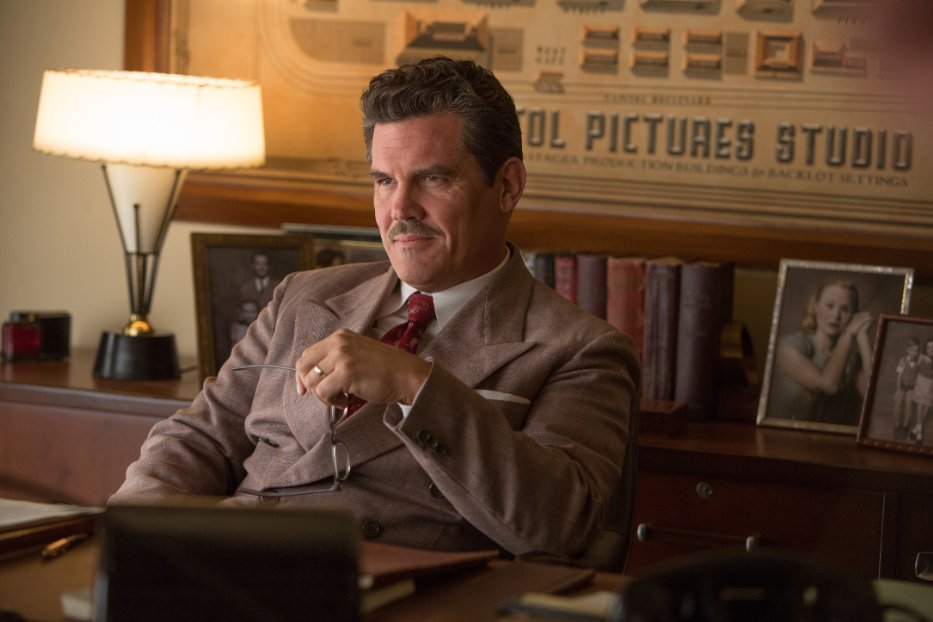Speculate on the possible advice Eddie Mannix might give to a newcomer in the film industry. Eddie Mannix might advise a newcomer in the film industry to always stay vigilant and prepared for the unexpected. He could emphasize the importance of building a strong network, maintaining an impeccable reputation, and being adaptable to the ever-changing dynamics of Hollywood. Additionally, he would likely stress the value of understanding both the business and creative sides of the industry, ensuring that one never loses sight of the delicate balance required to succeed. 